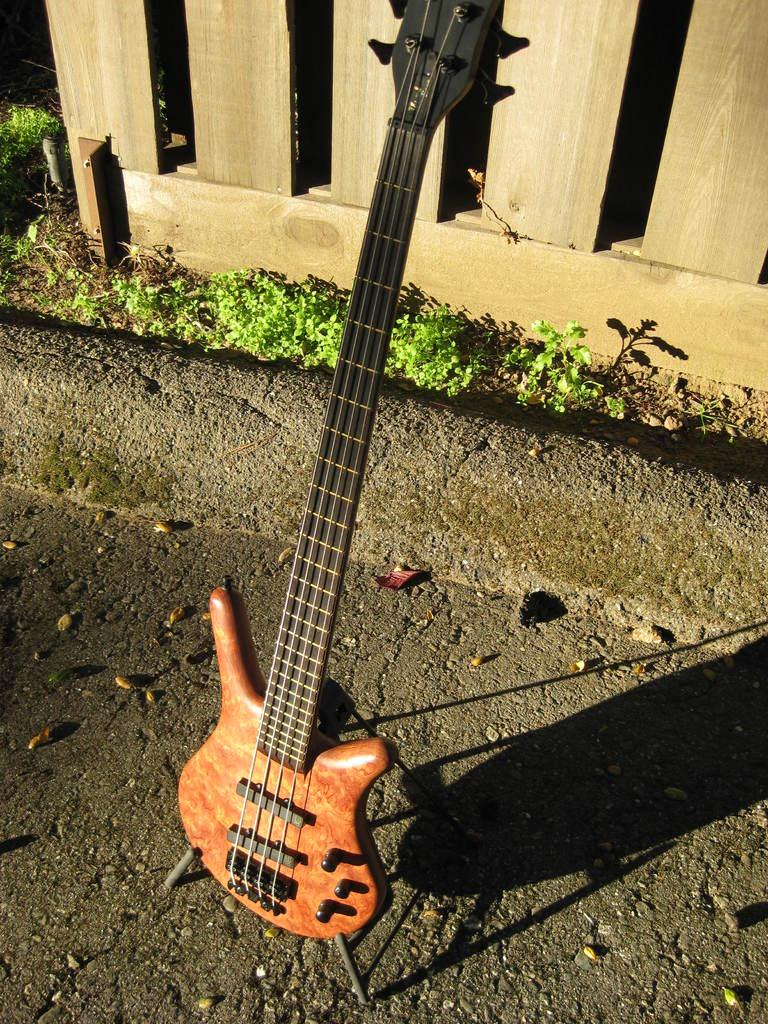What is the main object in the image? There is a guitar in the image. Where is the guitar located? The guitar is standing on a road. What does the mom do with the slip while standing near the guitar on the road? There is no mention of a mom or a slip in the image, so this question cannot be answered. 